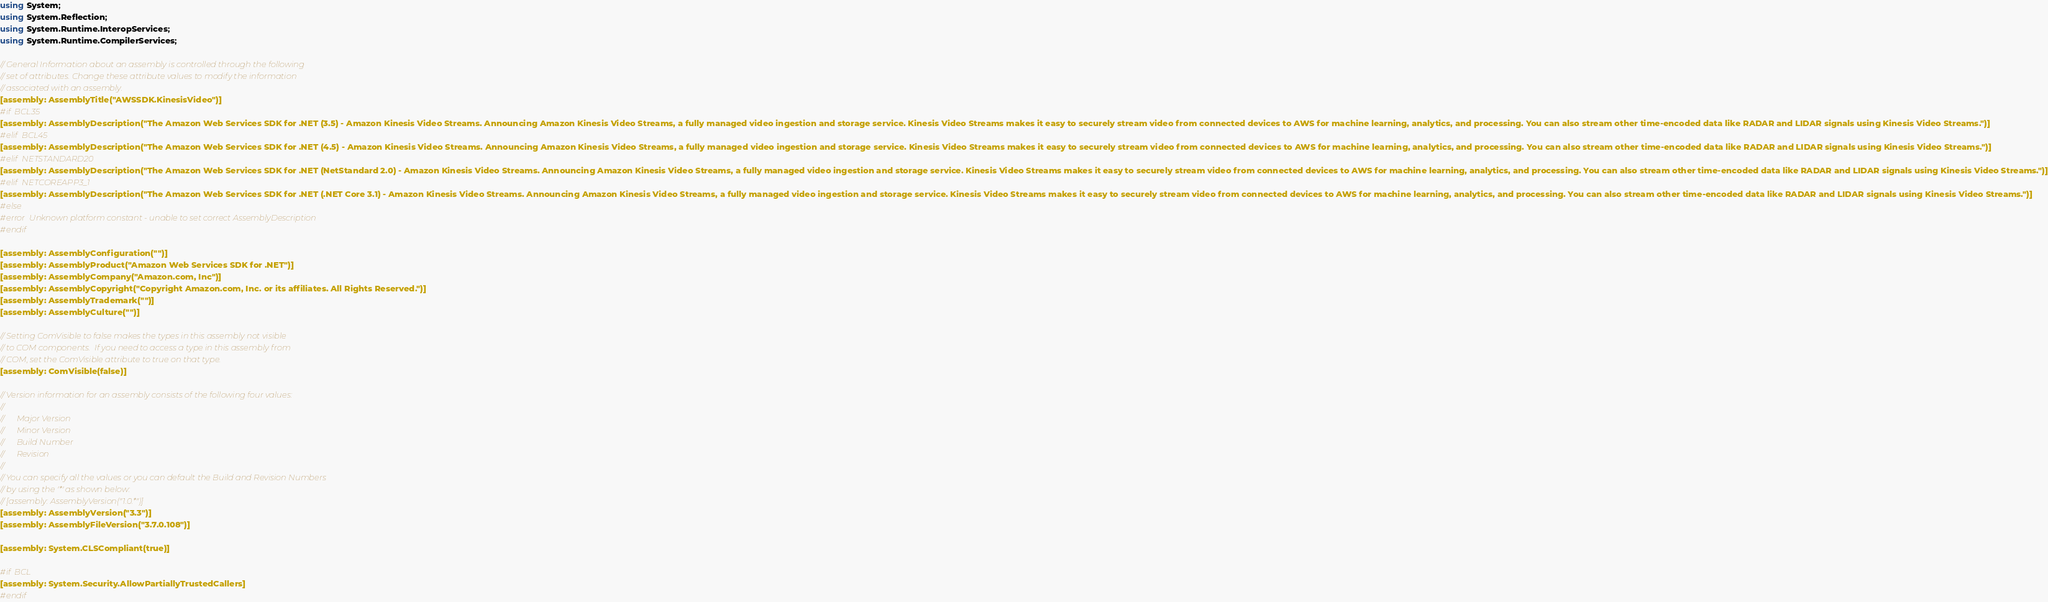Convert code to text. <code><loc_0><loc_0><loc_500><loc_500><_C#_>using System;
using System.Reflection;
using System.Runtime.InteropServices;
using System.Runtime.CompilerServices;

// General Information about an assembly is controlled through the following 
// set of attributes. Change these attribute values to modify the information
// associated with an assembly.
[assembly: AssemblyTitle("AWSSDK.KinesisVideo")]
#if BCL35
[assembly: AssemblyDescription("The Amazon Web Services SDK for .NET (3.5) - Amazon Kinesis Video Streams. Announcing Amazon Kinesis Video Streams, a fully managed video ingestion and storage service. Kinesis Video Streams makes it easy to securely stream video from connected devices to AWS for machine learning, analytics, and processing. You can also stream other time-encoded data like RADAR and LIDAR signals using Kinesis Video Streams.")]
#elif BCL45
[assembly: AssemblyDescription("The Amazon Web Services SDK for .NET (4.5) - Amazon Kinesis Video Streams. Announcing Amazon Kinesis Video Streams, a fully managed video ingestion and storage service. Kinesis Video Streams makes it easy to securely stream video from connected devices to AWS for machine learning, analytics, and processing. You can also stream other time-encoded data like RADAR and LIDAR signals using Kinesis Video Streams.")]
#elif NETSTANDARD20
[assembly: AssemblyDescription("The Amazon Web Services SDK for .NET (NetStandard 2.0) - Amazon Kinesis Video Streams. Announcing Amazon Kinesis Video Streams, a fully managed video ingestion and storage service. Kinesis Video Streams makes it easy to securely stream video from connected devices to AWS for machine learning, analytics, and processing. You can also stream other time-encoded data like RADAR and LIDAR signals using Kinesis Video Streams.")]
#elif NETCOREAPP3_1
[assembly: AssemblyDescription("The Amazon Web Services SDK for .NET (.NET Core 3.1) - Amazon Kinesis Video Streams. Announcing Amazon Kinesis Video Streams, a fully managed video ingestion and storage service. Kinesis Video Streams makes it easy to securely stream video from connected devices to AWS for machine learning, analytics, and processing. You can also stream other time-encoded data like RADAR and LIDAR signals using Kinesis Video Streams.")]
#else
#error Unknown platform constant - unable to set correct AssemblyDescription
#endif

[assembly: AssemblyConfiguration("")]
[assembly: AssemblyProduct("Amazon Web Services SDK for .NET")]
[assembly: AssemblyCompany("Amazon.com, Inc")]
[assembly: AssemblyCopyright("Copyright Amazon.com, Inc. or its affiliates. All Rights Reserved.")]
[assembly: AssemblyTrademark("")]
[assembly: AssemblyCulture("")]

// Setting ComVisible to false makes the types in this assembly not visible 
// to COM components.  If you need to access a type in this assembly from 
// COM, set the ComVisible attribute to true on that type.
[assembly: ComVisible(false)]

// Version information for an assembly consists of the following four values:
//
//      Major Version
//      Minor Version 
//      Build Number
//      Revision
//
// You can specify all the values or you can default the Build and Revision Numbers 
// by using the '*' as shown below:
// [assembly: AssemblyVersion("1.0.*")]
[assembly: AssemblyVersion("3.3")]
[assembly: AssemblyFileVersion("3.7.0.108")]

[assembly: System.CLSCompliant(true)]

#if BCL
[assembly: System.Security.AllowPartiallyTrustedCallers]
#endif</code> 